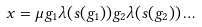<formula> <loc_0><loc_0><loc_500><loc_500>x = \mu g _ { 1 } \lambda ( s ( g _ { 1 } ) ) g _ { 2 } \lambda ( s ( g _ { 2 } ) ) \dots</formula> 